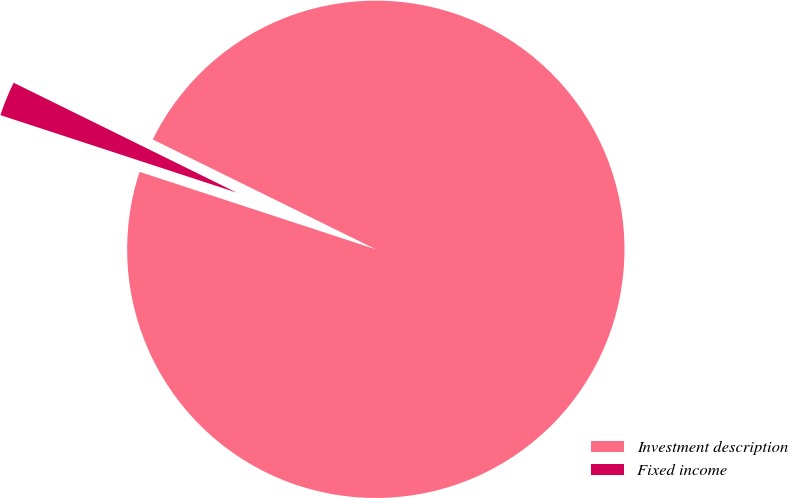Convert chart. <chart><loc_0><loc_0><loc_500><loc_500><pie_chart><fcel>Investment description<fcel>Fixed income<nl><fcel>97.76%<fcel>2.24%<nl></chart> 